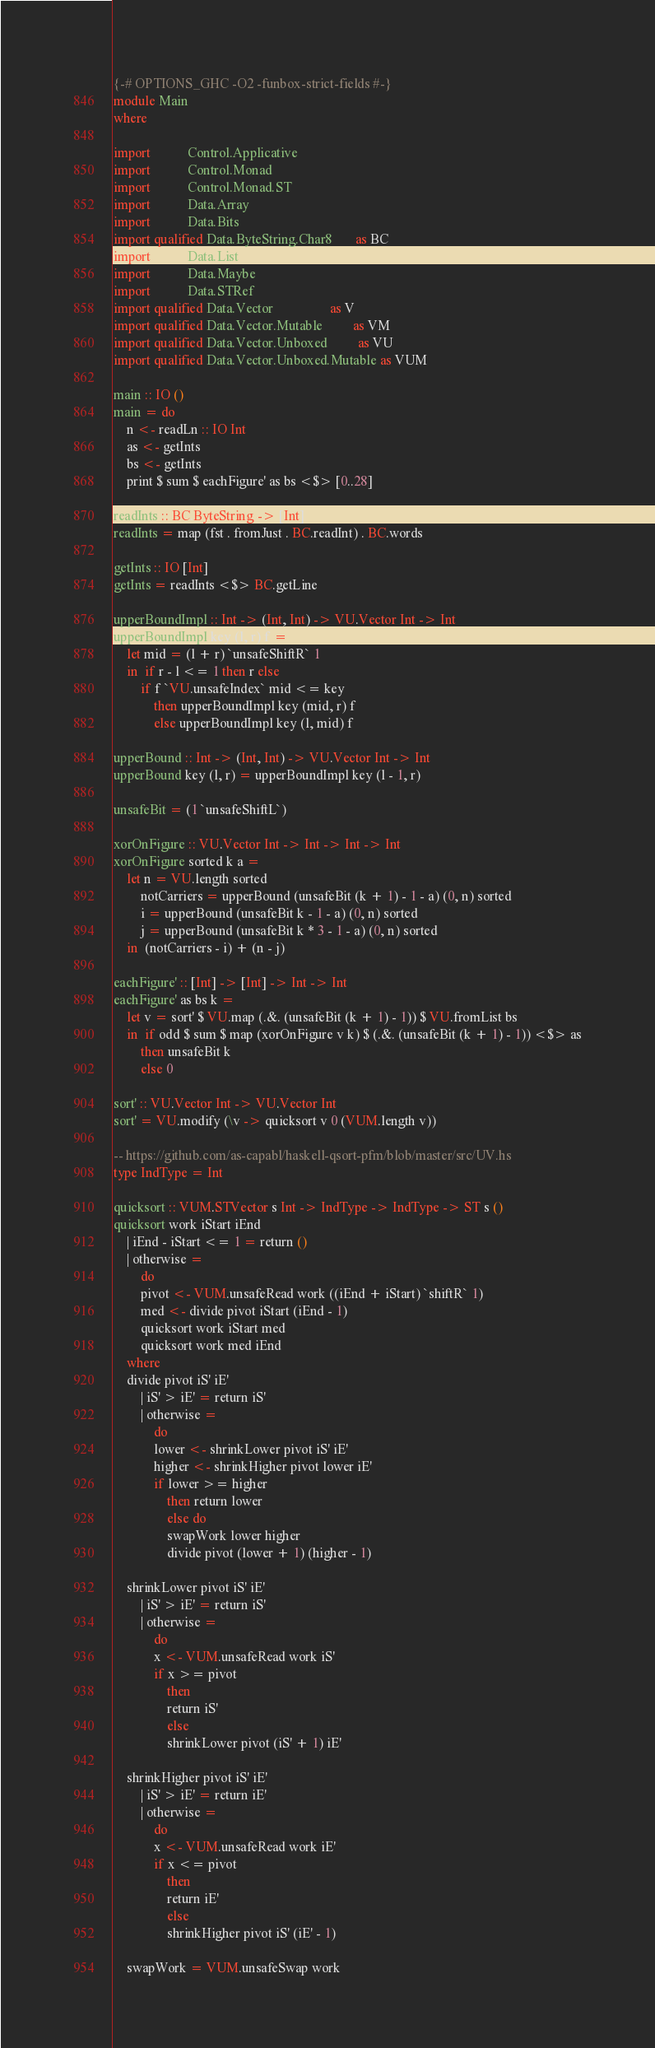<code> <loc_0><loc_0><loc_500><loc_500><_Haskell_>{-# OPTIONS_GHC -O2 -funbox-strict-fields #-}
module Main
where

import           Control.Applicative
import           Control.Monad
import           Control.Monad.ST
import           Data.Array
import           Data.Bits
import qualified Data.ByteString.Char8       as BC
import           Data.List
import           Data.Maybe
import           Data.STRef
import qualified Data.Vector                 as V
import qualified Data.Vector.Mutable         as VM
import qualified Data.Vector.Unboxed         as VU
import qualified Data.Vector.Unboxed.Mutable as VUM

main :: IO ()
main = do
    n <- readLn :: IO Int
    as <- getInts
    bs <- getInts
    print $ sum $ eachFigure' as bs <$> [0..28]

readInts :: BC.ByteString -> [Int]
readInts = map (fst . fromJust . BC.readInt) . BC.words

getInts :: IO [Int]
getInts = readInts <$> BC.getLine

upperBoundImpl :: Int -> (Int, Int) -> VU.Vector Int -> Int
upperBoundImpl key (l, r) f =
    let mid = (l + r) `unsafeShiftR` 1
    in  if r - l <= 1 then r else
        if f `VU.unsafeIndex` mid <= key
            then upperBoundImpl key (mid, r) f
            else upperBoundImpl key (l, mid) f

upperBound :: Int -> (Int, Int) -> VU.Vector Int -> Int
upperBound key (l, r) = upperBoundImpl key (l - 1, r)

unsafeBit = (1 `unsafeShiftL`)

xorOnFigure :: VU.Vector Int -> Int -> Int -> Int
xorOnFigure sorted k a =
    let n = VU.length sorted
        notCarriers = upperBound (unsafeBit (k + 1) - 1 - a) (0, n) sorted
        i = upperBound (unsafeBit k - 1 - a) (0, n) sorted
        j = upperBound (unsafeBit k * 3 - 1 - a) (0, n) sorted
    in  (notCarriers - i) + (n - j)

eachFigure' :: [Int] -> [Int] -> Int -> Int
eachFigure' as bs k =
    let v = sort' $ VU.map (.&. (unsafeBit (k + 1) - 1)) $ VU.fromList bs
    in  if odd $ sum $ map (xorOnFigure v k) $ (.&. (unsafeBit (k + 1) - 1)) <$> as
        then unsafeBit k
        else 0
        
sort' :: VU.Vector Int -> VU.Vector Int
sort' = VU.modify (\v -> quicksort v 0 (VUM.length v))

-- https://github.com/as-capabl/haskell-qsort-pfm/blob/master/src/UV.hs
type IndType = Int

quicksort :: VUM.STVector s Int -> IndType -> IndType -> ST s ()
quicksort work iStart iEnd
    | iEnd - iStart <= 1 = return ()
    | otherwise =
        do
        pivot <- VUM.unsafeRead work ((iEnd + iStart) `shiftR` 1)
        med <- divide pivot iStart (iEnd - 1)
        quicksort work iStart med
        quicksort work med iEnd
    where
    divide pivot iS' iE'
        | iS' > iE' = return iS'
        | otherwise =
            do
            lower <- shrinkLower pivot iS' iE'
            higher <- shrinkHigher pivot lower iE'
            if lower >= higher
                then return lower
                else do
                swapWork lower higher
                divide pivot (lower + 1) (higher - 1)

    shrinkLower pivot iS' iE'
        | iS' > iE' = return iS'
        | otherwise =
            do
            x <- VUM.unsafeRead work iS'
            if x >= pivot
                then
                return iS'
                else
                shrinkLower pivot (iS' + 1) iE'

    shrinkHigher pivot iS' iE'
        | iS' > iE' = return iE'
        | otherwise =
            do
            x <- VUM.unsafeRead work iE'
            if x <= pivot
                then
                return iE'
                else
                shrinkHigher pivot iS' (iE' - 1)

    swapWork = VUM.unsafeSwap work
</code> 